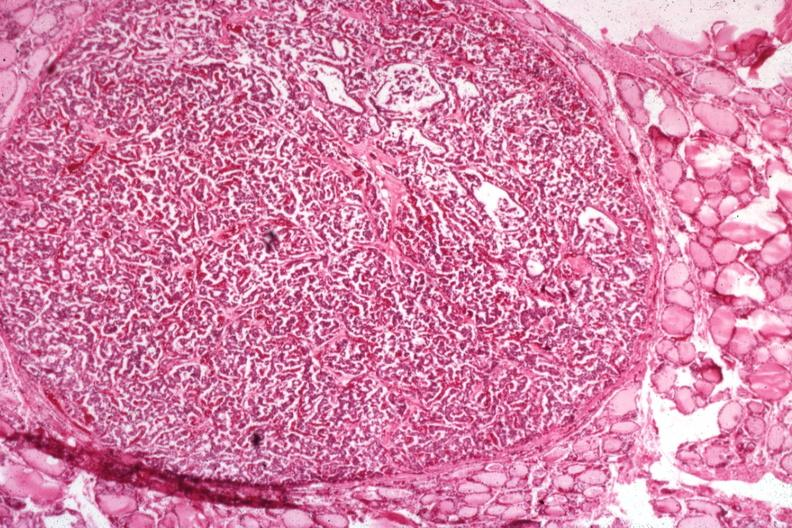what is present?
Answer the question using a single word or phrase. Papillary adenoma 